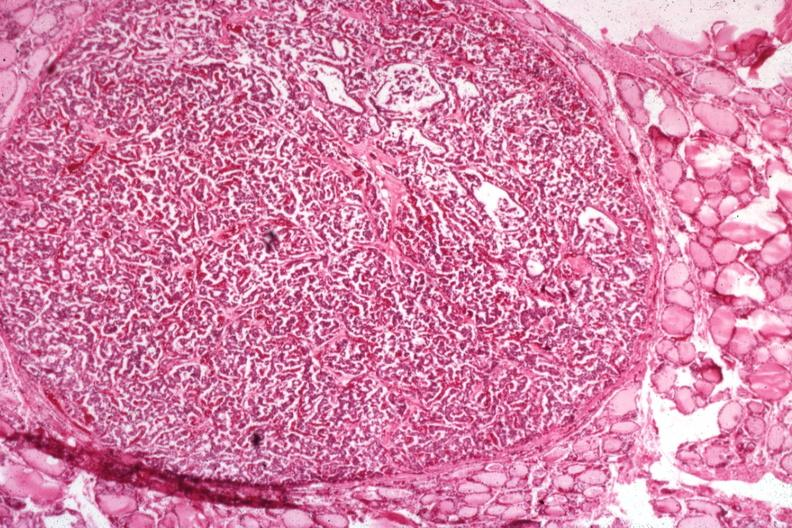what is present?
Answer the question using a single word or phrase. Papillary adenoma 